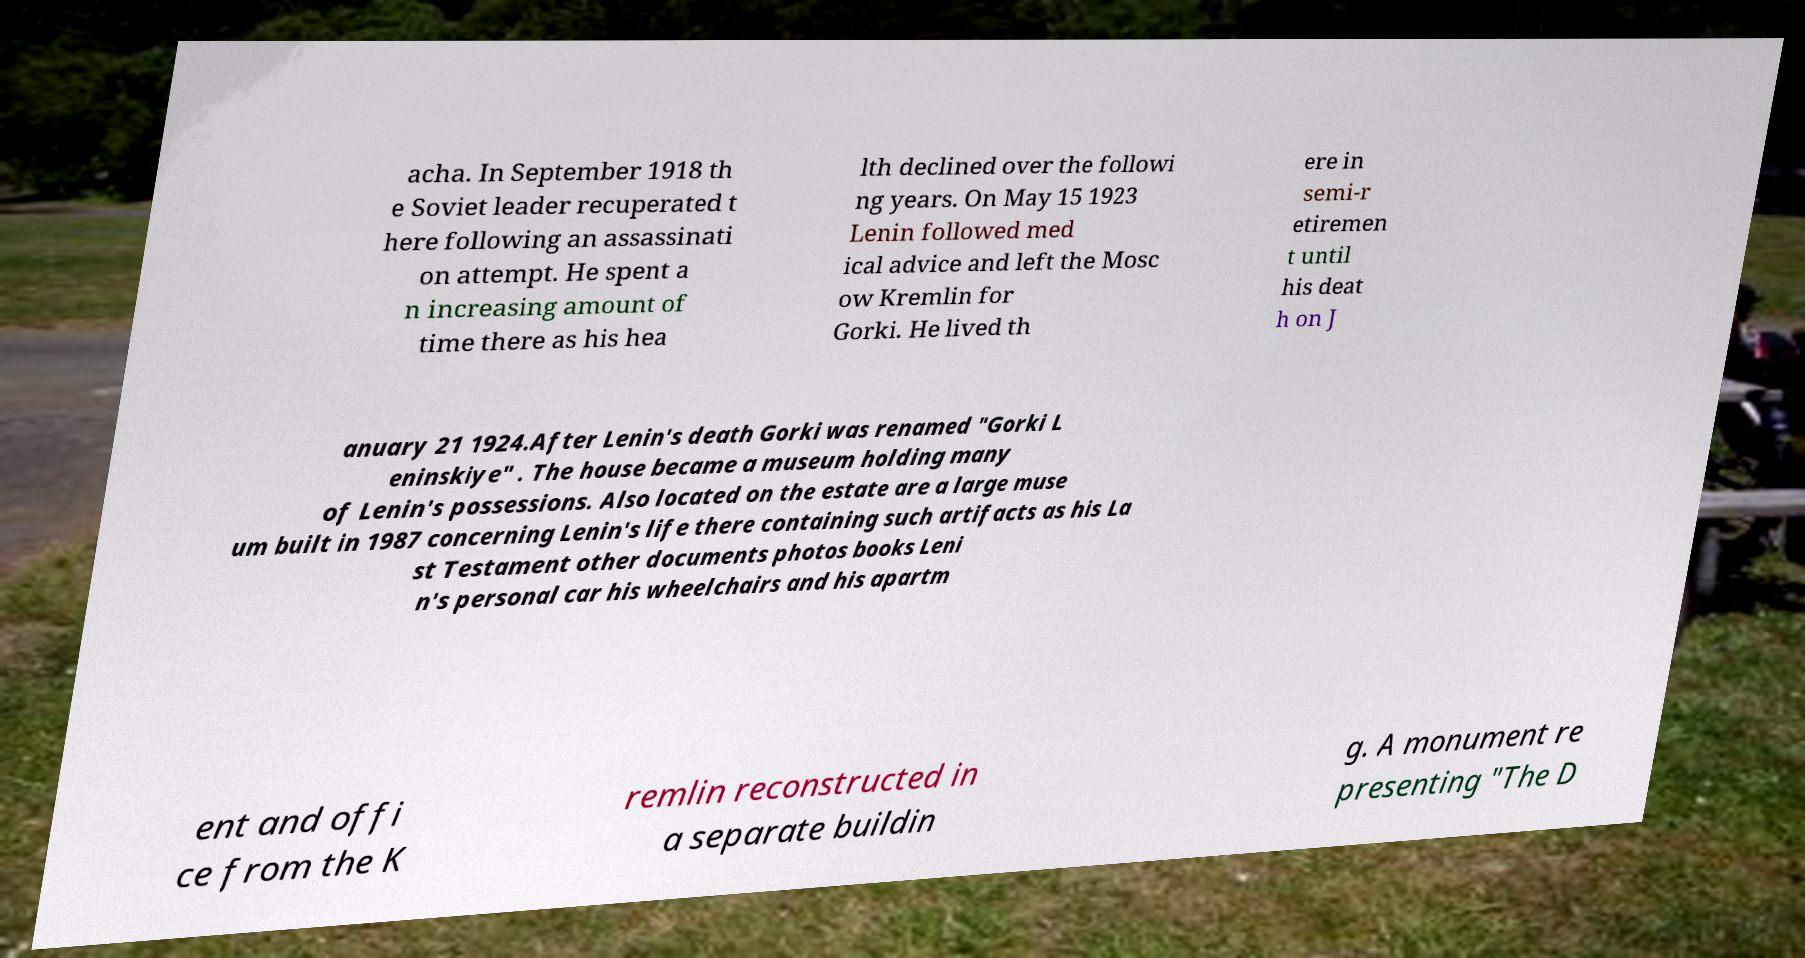Please read and relay the text visible in this image. What does it say? acha. In September 1918 th e Soviet leader recuperated t here following an assassinati on attempt. He spent a n increasing amount of time there as his hea lth declined over the followi ng years. On May 15 1923 Lenin followed med ical advice and left the Mosc ow Kremlin for Gorki. He lived th ere in semi-r etiremen t until his deat h on J anuary 21 1924.After Lenin's death Gorki was renamed "Gorki L eninskiye" . The house became a museum holding many of Lenin's possessions. Also located on the estate are a large muse um built in 1987 concerning Lenin's life there containing such artifacts as his La st Testament other documents photos books Leni n's personal car his wheelchairs and his apartm ent and offi ce from the K remlin reconstructed in a separate buildin g. A monument re presenting "The D 